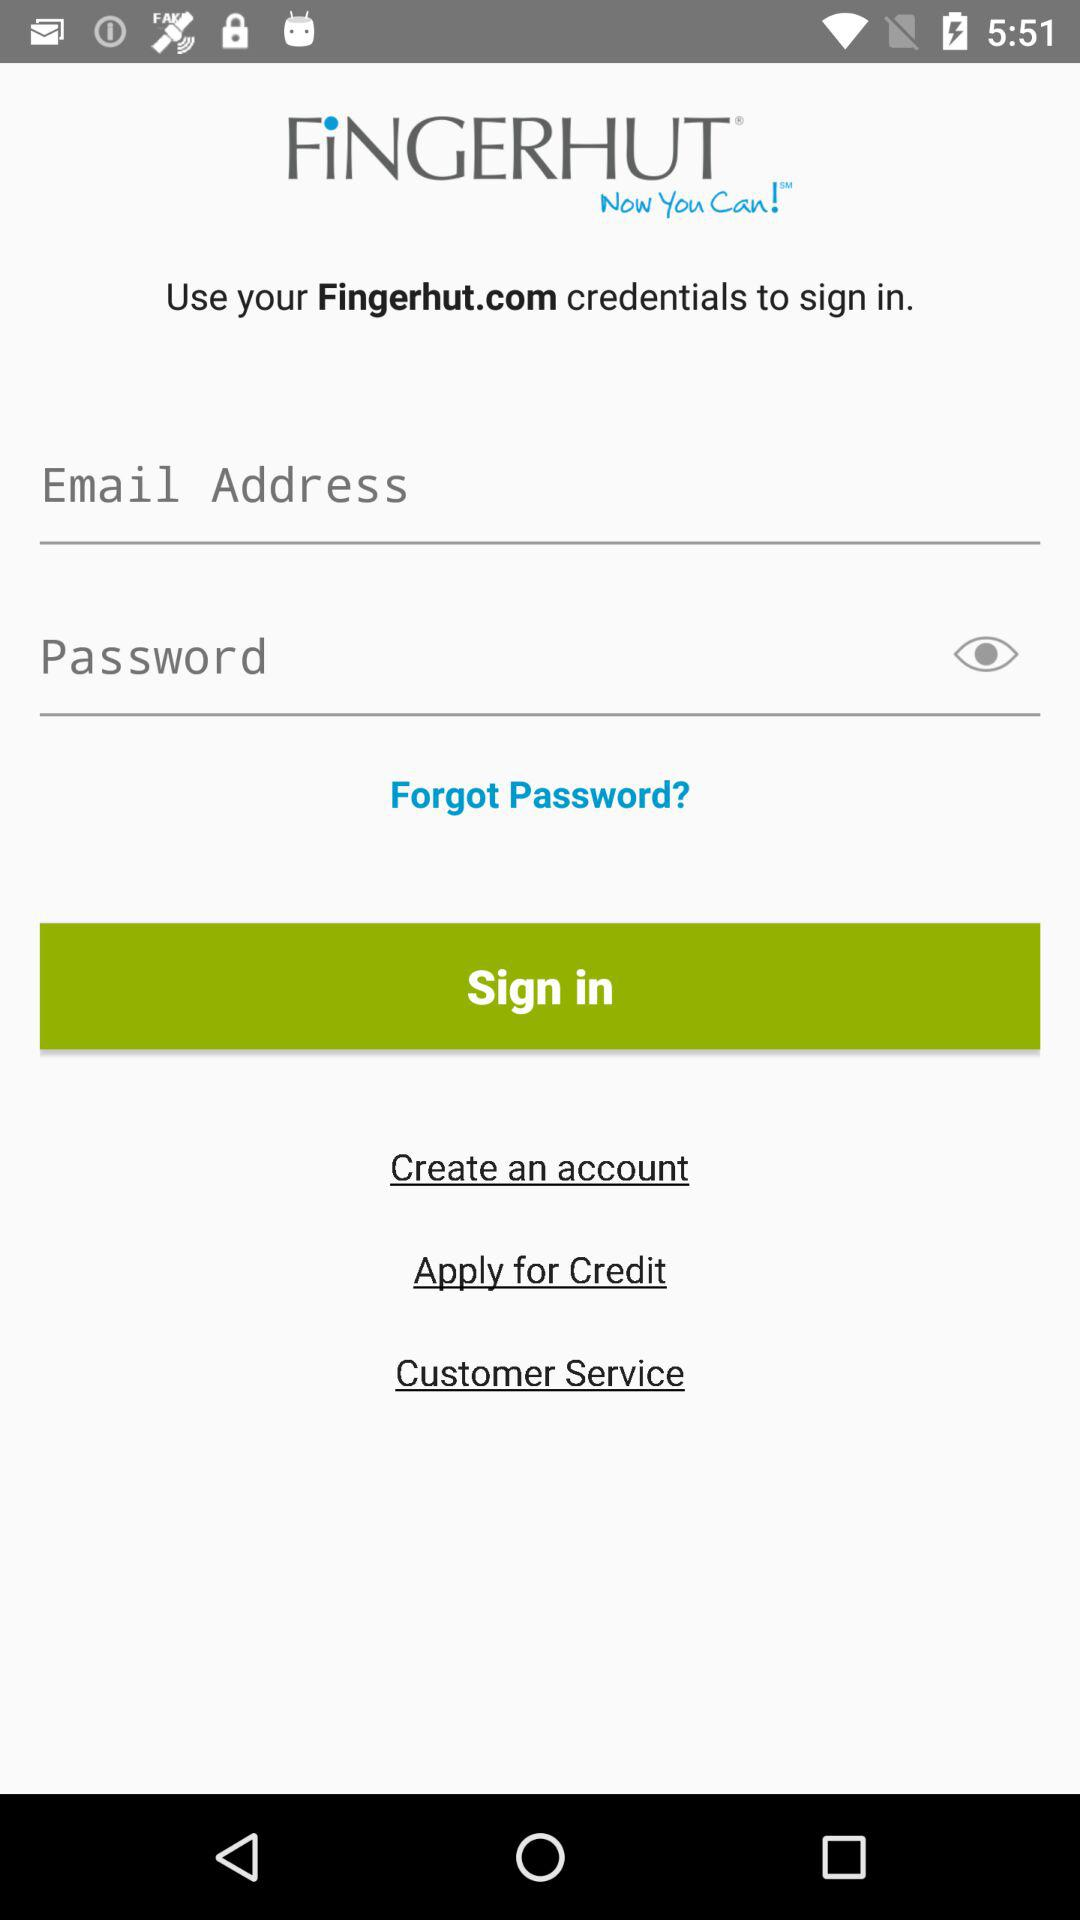What is the application name? The application name is "FINGERHUT". 